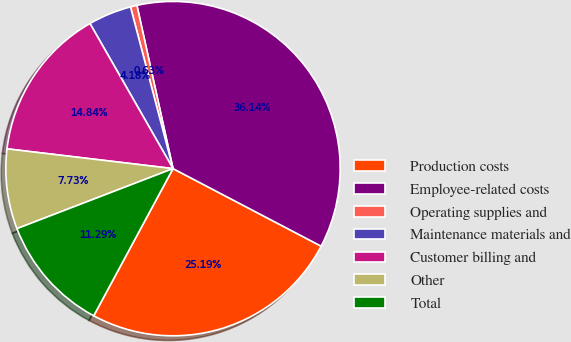<chart> <loc_0><loc_0><loc_500><loc_500><pie_chart><fcel>Production costs<fcel>Employee-related costs<fcel>Operating supplies and<fcel>Maintenance materials and<fcel>Customer billing and<fcel>Other<fcel>Total<nl><fcel>25.19%<fcel>36.14%<fcel>0.63%<fcel>4.18%<fcel>14.84%<fcel>7.73%<fcel>11.29%<nl></chart> 